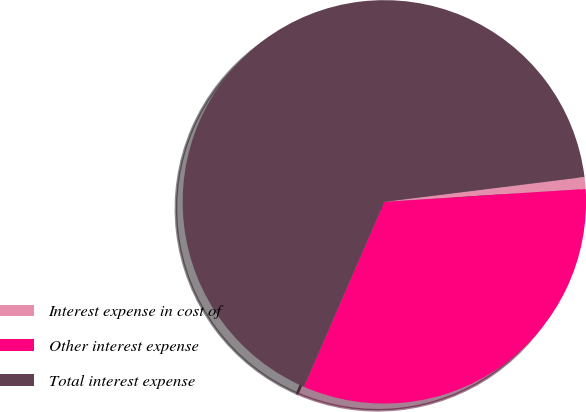Convert chart to OTSL. <chart><loc_0><loc_0><loc_500><loc_500><pie_chart><fcel>Interest expense in cost of<fcel>Other interest expense<fcel>Total interest expense<nl><fcel>0.95%<fcel>32.54%<fcel>66.51%<nl></chart> 